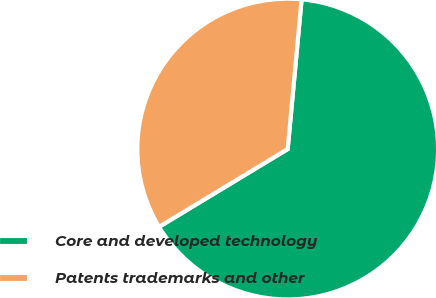Convert chart. <chart><loc_0><loc_0><loc_500><loc_500><pie_chart><fcel>Core and developed technology<fcel>Patents trademarks and other<nl><fcel>64.87%<fcel>35.13%<nl></chart> 